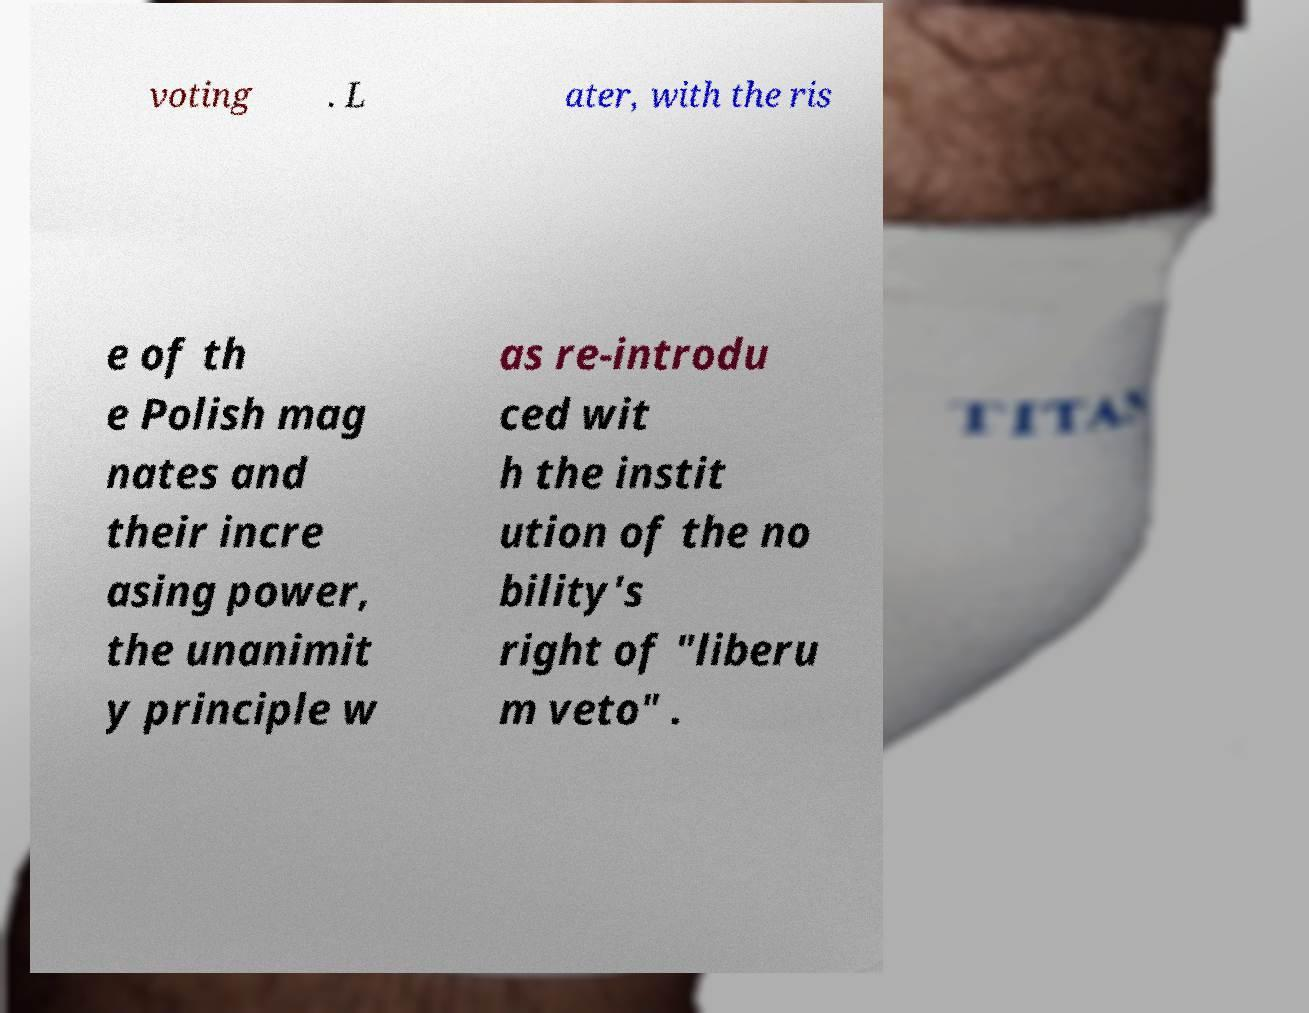I need the written content from this picture converted into text. Can you do that? voting . L ater, with the ris e of th e Polish mag nates and their incre asing power, the unanimit y principle w as re-introdu ced wit h the instit ution of the no bility's right of "liberu m veto" . 